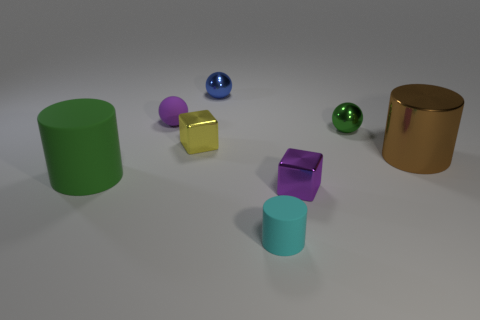Add 1 tiny green metal things. How many objects exist? 9 Subtract all cylinders. How many objects are left? 5 Subtract 1 cyan cylinders. How many objects are left? 7 Subtract all large cylinders. Subtract all small cyan shiny objects. How many objects are left? 6 Add 4 small purple shiny cubes. How many small purple shiny cubes are left? 5 Add 5 purple matte objects. How many purple matte objects exist? 6 